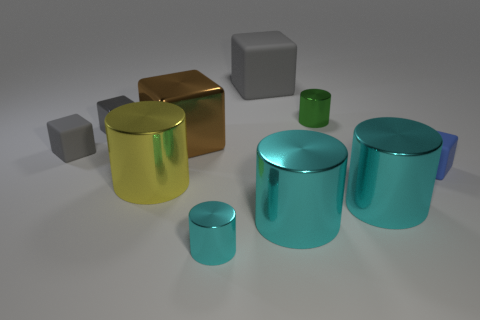There is a brown shiny cube that is left of the small cube right of the large brown metal block; how big is it?
Make the answer very short. Large. Is there a small purple sphere?
Offer a very short reply. No. There is a small gray shiny thing that is in front of the green shiny object; how many gray rubber objects are in front of it?
Your answer should be very brief. 1. There is a brown object to the right of the yellow metal thing; what is its shape?
Make the answer very short. Cube. There is a small cylinder that is in front of the small green cylinder that is right of the tiny matte object that is left of the small blue matte object; what is its material?
Ensure brevity in your answer.  Metal. How many other things are the same size as the blue rubber cube?
Provide a short and direct response. 4. What material is the big gray thing that is the same shape as the blue object?
Your response must be concise. Rubber. What is the color of the big metal block?
Offer a terse response. Brown. The matte object on the right side of the gray thing on the right side of the brown metal cube is what color?
Provide a succinct answer. Blue. Does the small metallic cube have the same color as the tiny thing behind the tiny metal cube?
Ensure brevity in your answer.  No. 